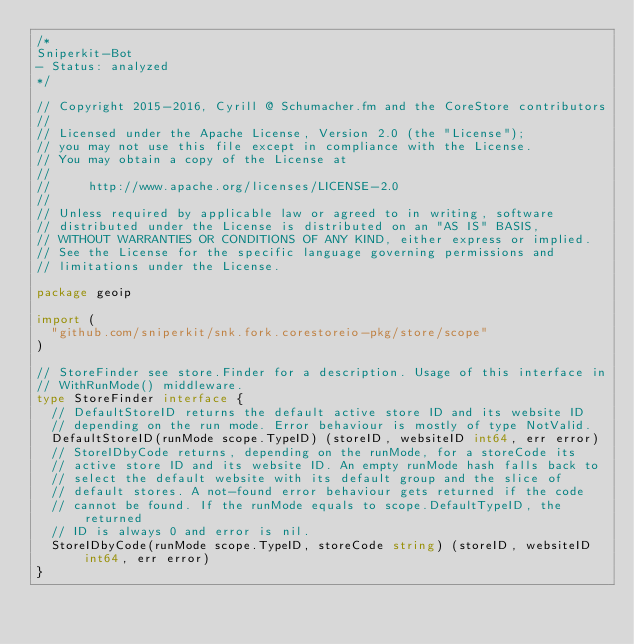<code> <loc_0><loc_0><loc_500><loc_500><_Go_>/*
Sniperkit-Bot
- Status: analyzed
*/

// Copyright 2015-2016, Cyrill @ Schumacher.fm and the CoreStore contributors
//
// Licensed under the Apache License, Version 2.0 (the "License");
// you may not use this file except in compliance with the License.
// You may obtain a copy of the License at
//
//     http://www.apache.org/licenses/LICENSE-2.0
//
// Unless required by applicable law or agreed to in writing, software
// distributed under the License is distributed on an "AS IS" BASIS,
// WITHOUT WARRANTIES OR CONDITIONS OF ANY KIND, either express or implied.
// See the License for the specific language governing permissions and
// limitations under the License.

package geoip

import (
	"github.com/sniperkit/snk.fork.corestoreio-pkg/store/scope"
)

// StoreFinder see store.Finder for a description. Usage of this interface in
// WithRunMode() middleware.
type StoreFinder interface {
	// DefaultStoreID returns the default active store ID and its website ID
	// depending on the run mode. Error behaviour is mostly of type NotValid.
	DefaultStoreID(runMode scope.TypeID) (storeID, websiteID int64, err error)
	// StoreIDbyCode returns, depending on the runMode, for a storeCode its
	// active store ID and its website ID. An empty runMode hash falls back to
	// select the default website with its default group and the slice of
	// default stores. A not-found error behaviour gets returned if the code
	// cannot be found. If the runMode equals to scope.DefaultTypeID, the returned
	// ID is always 0 and error is nil.
	StoreIDbyCode(runMode scope.TypeID, storeCode string) (storeID, websiteID int64, err error)
}
</code> 